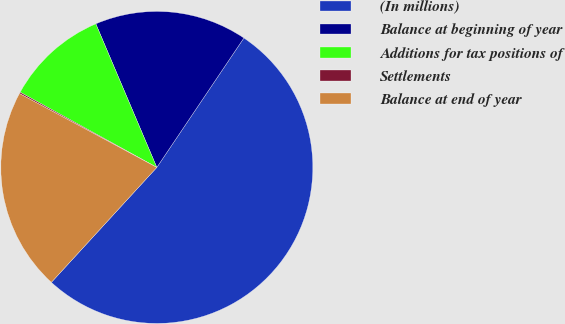<chart> <loc_0><loc_0><loc_500><loc_500><pie_chart><fcel>(In millions)<fcel>Balance at beginning of year<fcel>Additions for tax positions of<fcel>Settlements<fcel>Balance at end of year<nl><fcel>52.39%<fcel>15.82%<fcel>10.6%<fcel>0.15%<fcel>21.04%<nl></chart> 